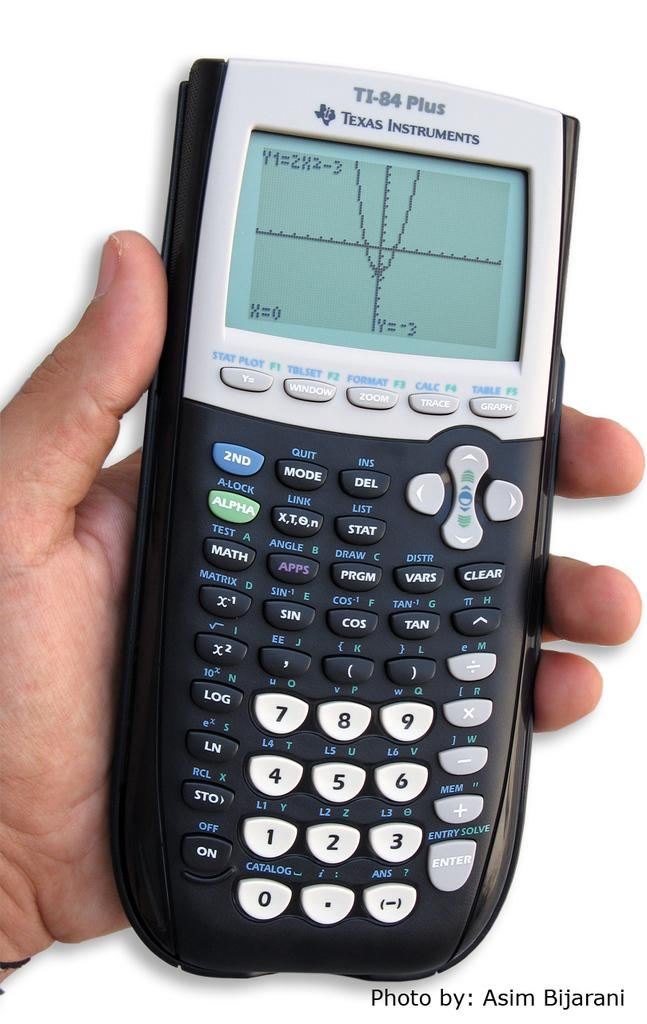<image>
Relay a brief, clear account of the picture shown. A person is holding a calculator that says Texas Instruments. 